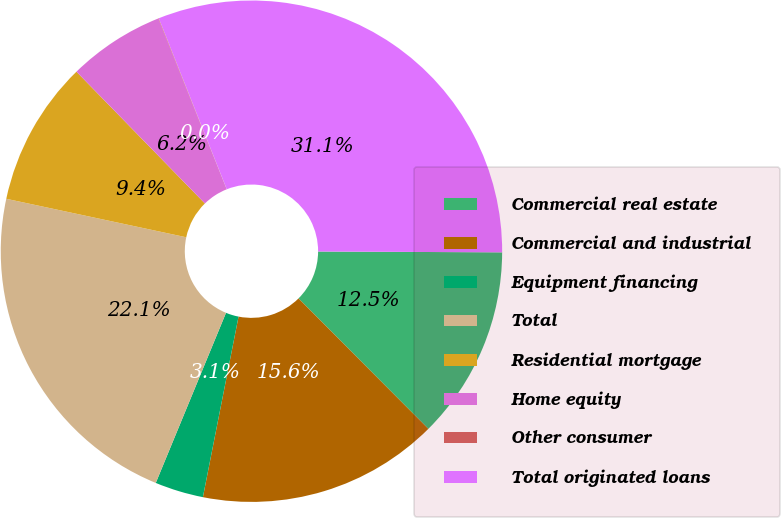Convert chart to OTSL. <chart><loc_0><loc_0><loc_500><loc_500><pie_chart><fcel>Commercial real estate<fcel>Commercial and industrial<fcel>Equipment financing<fcel>Total<fcel>Residential mortgage<fcel>Home equity<fcel>Other consumer<fcel>Total originated loans<nl><fcel>12.46%<fcel>15.57%<fcel>3.13%<fcel>22.12%<fcel>9.35%<fcel>6.24%<fcel>0.03%<fcel>31.1%<nl></chart> 